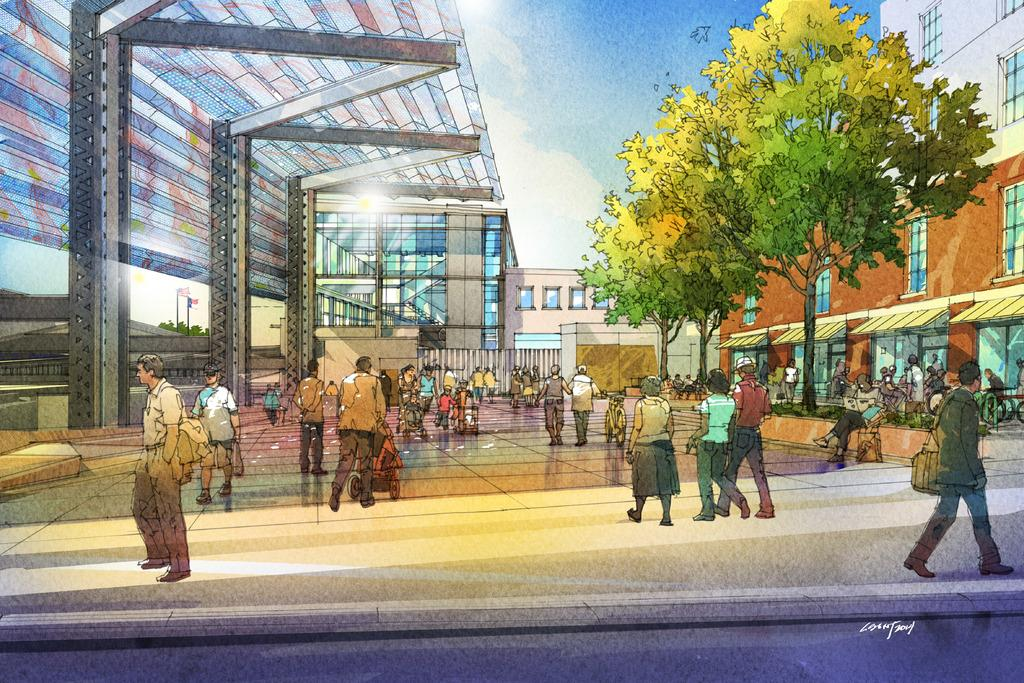What is the main subject of the image? The main subject of the image is a painting. What can be seen in the painting? The painting contains a group of people, buildings, and trees. What type of food is being served by the doctor in the image? There is no doctor or food present in the image; it features a painting with a group of people, buildings, and trees. 